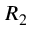<formula> <loc_0><loc_0><loc_500><loc_500>R _ { 2 }</formula> 